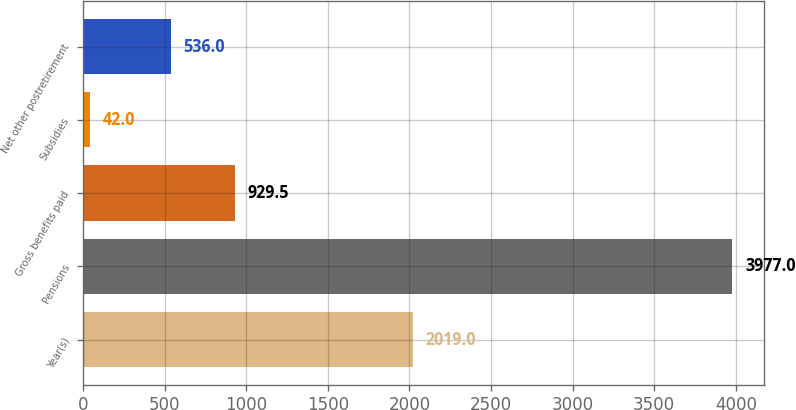Convert chart. <chart><loc_0><loc_0><loc_500><loc_500><bar_chart><fcel>Year(s)<fcel>Pensions<fcel>Gross benefits paid<fcel>Subsidies<fcel>Net other postretirement<nl><fcel>2019<fcel>3977<fcel>929.5<fcel>42<fcel>536<nl></chart> 